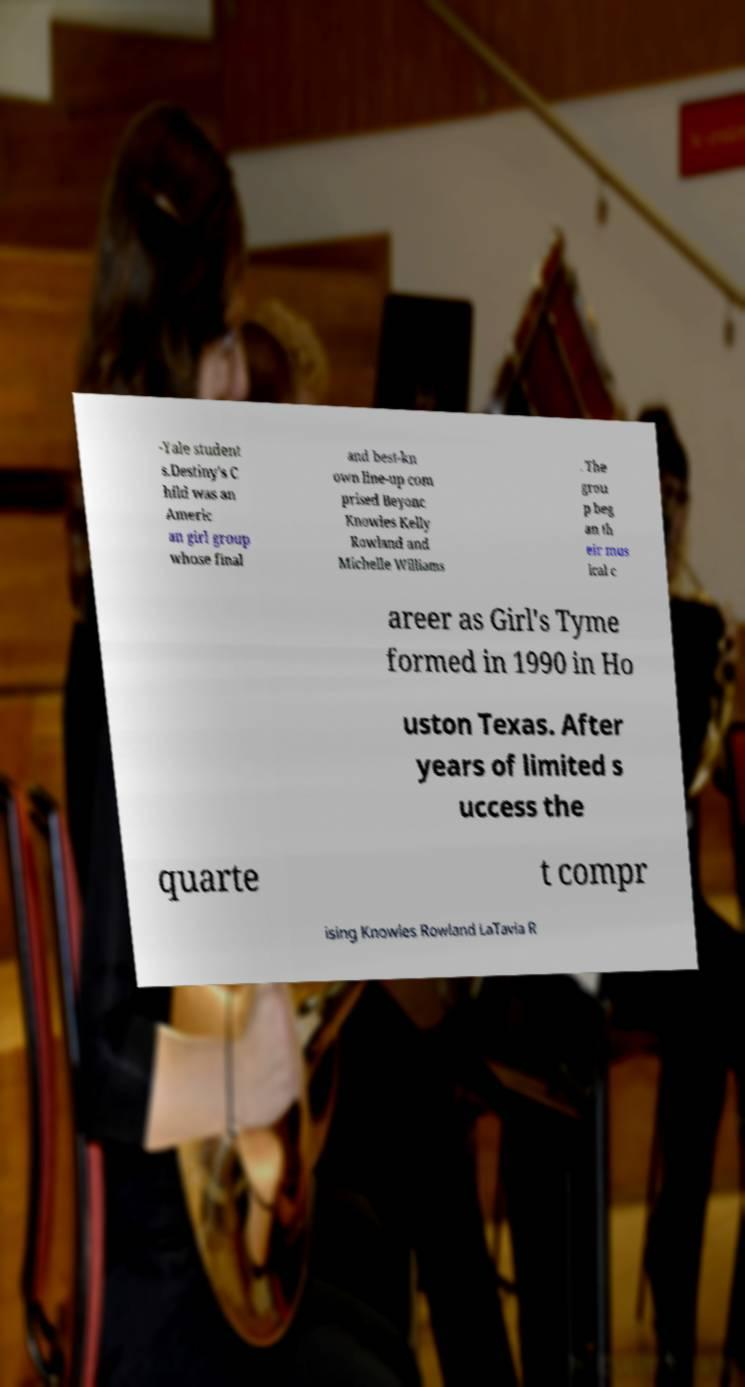For documentation purposes, I need the text within this image transcribed. Could you provide that? -Yale student s.Destiny's C hild was an Americ an girl group whose final and best-kn own line-up com prised Beyonc Knowles Kelly Rowland and Michelle Williams . The grou p beg an th eir mus ical c areer as Girl's Tyme formed in 1990 in Ho uston Texas. After years of limited s uccess the quarte t compr ising Knowles Rowland LaTavia R 